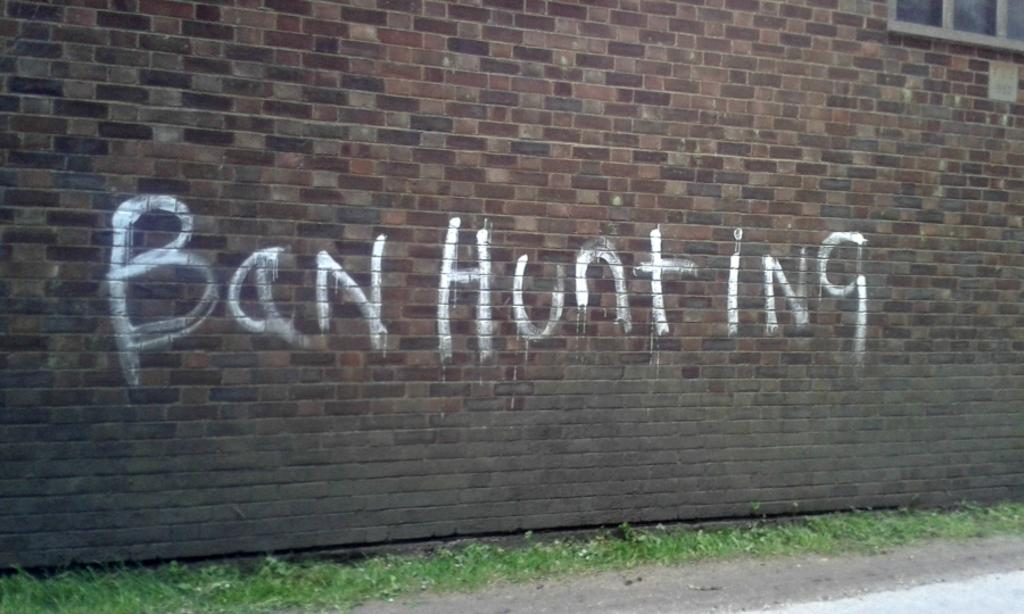What is the main structure in the center of the image? There is a building in the center of the image. What other architectural feature can be seen in the image? There is a wall in the image. What is written or displayed on the wall? There is text on the wall. What type of path is visible at the bottom of the image? There is a walkway at the bottom of the image. What type of vegetation is present in the image? There is grass in the image. How many birds are in the flock flying over the building in the image? There are no birds or flocks visible in the image; it only features a building, a wall, text, a walkway, and grass. 